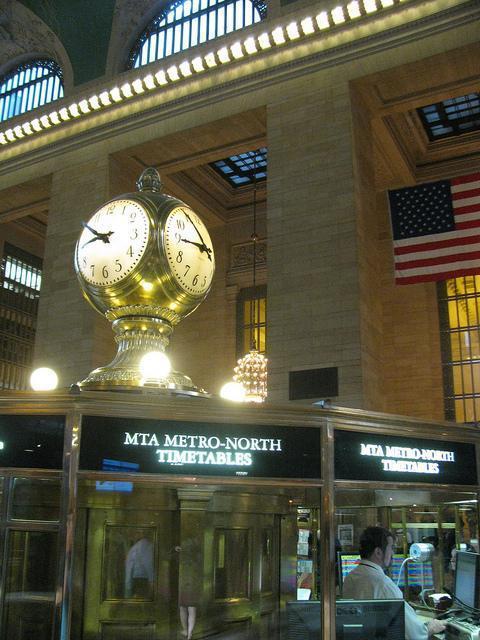How many people are there?
Give a very brief answer. 2. How many clocks are in the picture?
Give a very brief answer. 2. 